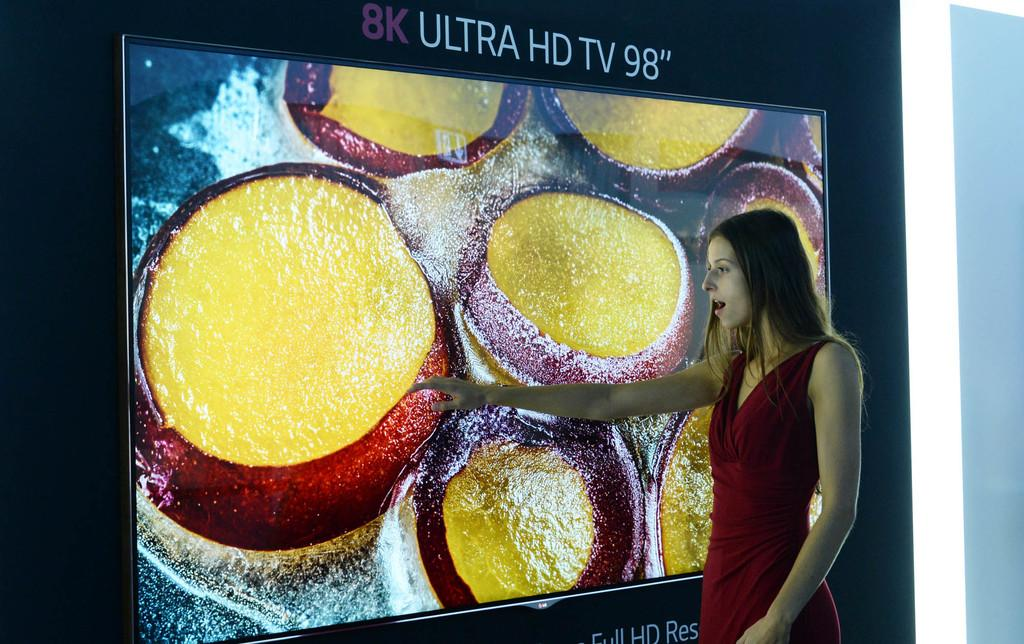What is the main object in the image? There is a screen in the image. What can be seen on the screen? There is written text at the top of the screen, and a girl is watching a food item on the screen. Who is present in the image? There is a girl in the image. What direction is the girl facing in the image? The provided facts do not mention the direction the girl is facing, so we cannot definitively answer this question. Is there a button on the screen that the girl is pressing? There is no mention of a button on the screen in the provided facts, so we cannot definitively answer this question. 